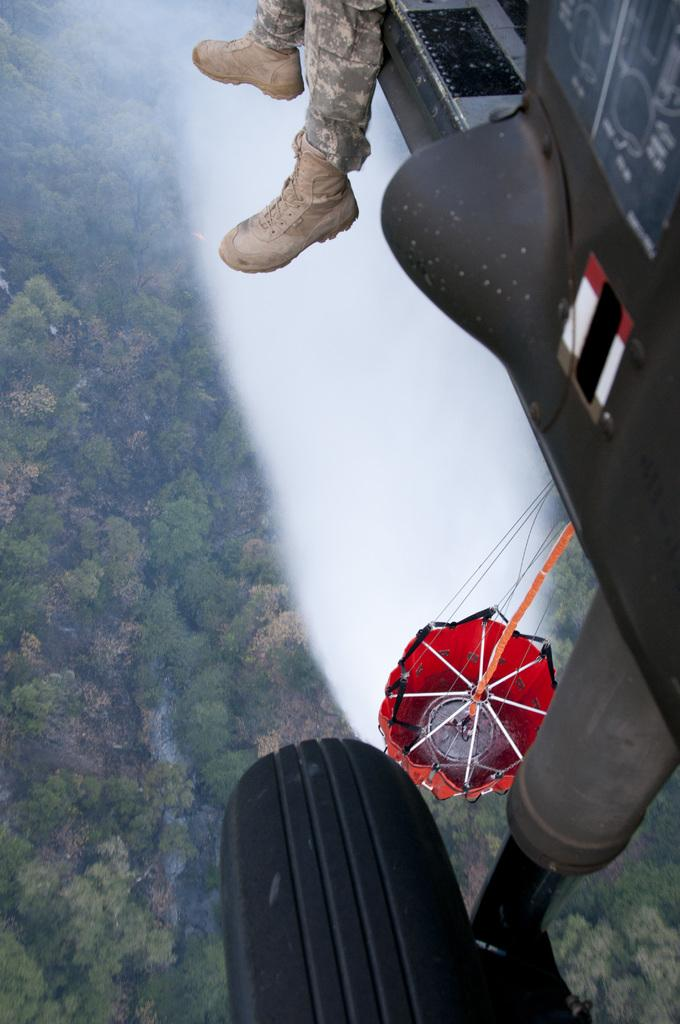What body part is visible at the top of the image? There are person's legs visible at the top of the image. What mode of transportation can be seen in the image? There is an aeroplane in the image. What safety device is present in the center of the image? A parachute is present in the center of the image. What type of natural scenery is visible in the background of the image? There are trees in the background of the image. Can you see a giraffe in the image? No, there is no giraffe present in the image. What sound does the bell make in the image? There is no bell present in the image. 